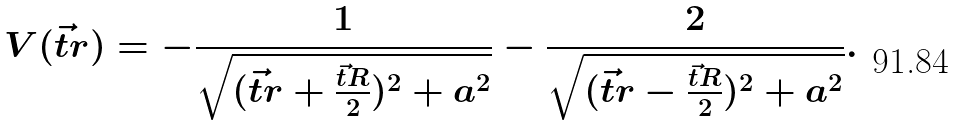<formula> <loc_0><loc_0><loc_500><loc_500>V ( \vec { t } { r } ) = - \frac { 1 } { \sqrt { ( \vec { t } { r } + \frac { \vec { t } { R } } { 2 } ) ^ { 2 } + a ^ { 2 } } } - \frac { 2 } { \sqrt { ( \vec { t } { r } - \frac { \vec { t } { R } } { 2 } ) ^ { 2 } + a ^ { 2 } } } .</formula> 